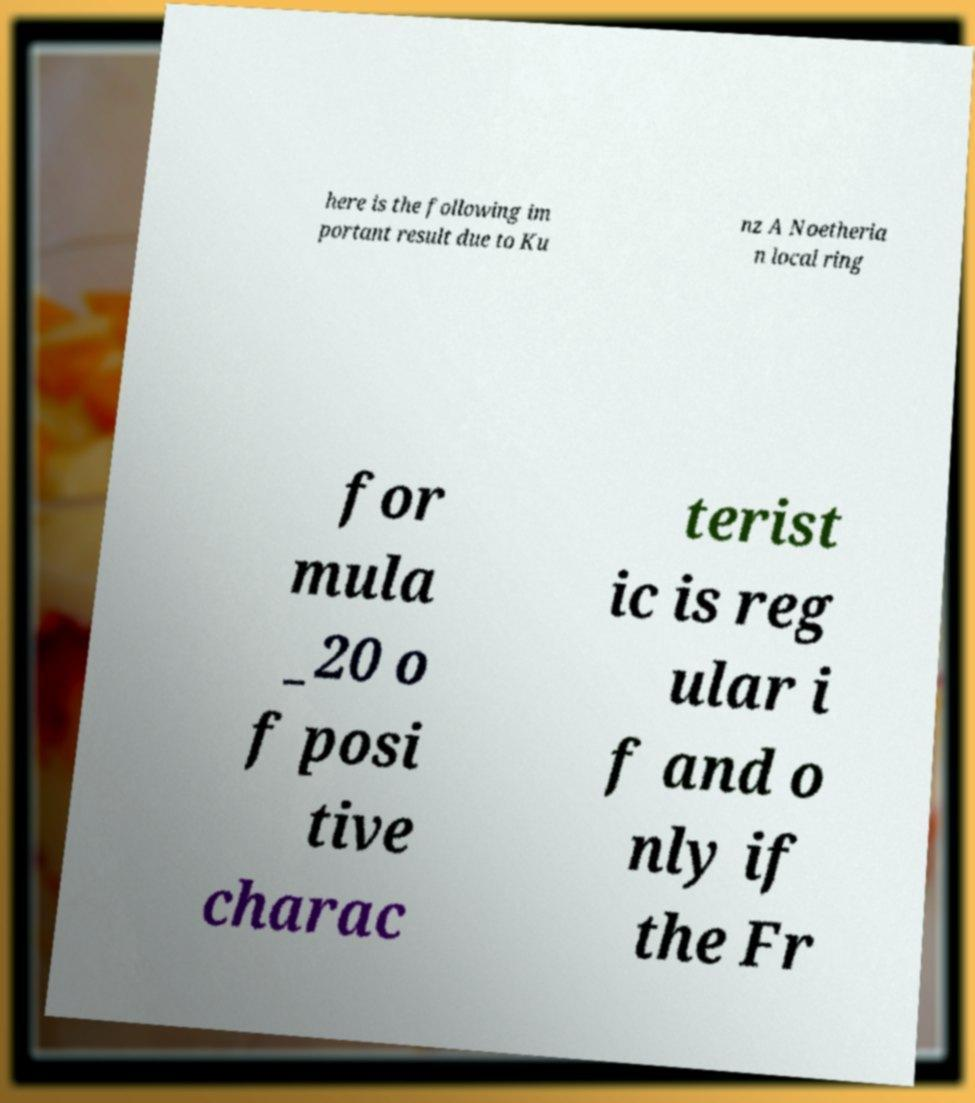Can you accurately transcribe the text from the provided image for me? here is the following im portant result due to Ku nz A Noetheria n local ring for mula _20 o f posi tive charac terist ic is reg ular i f and o nly if the Fr 